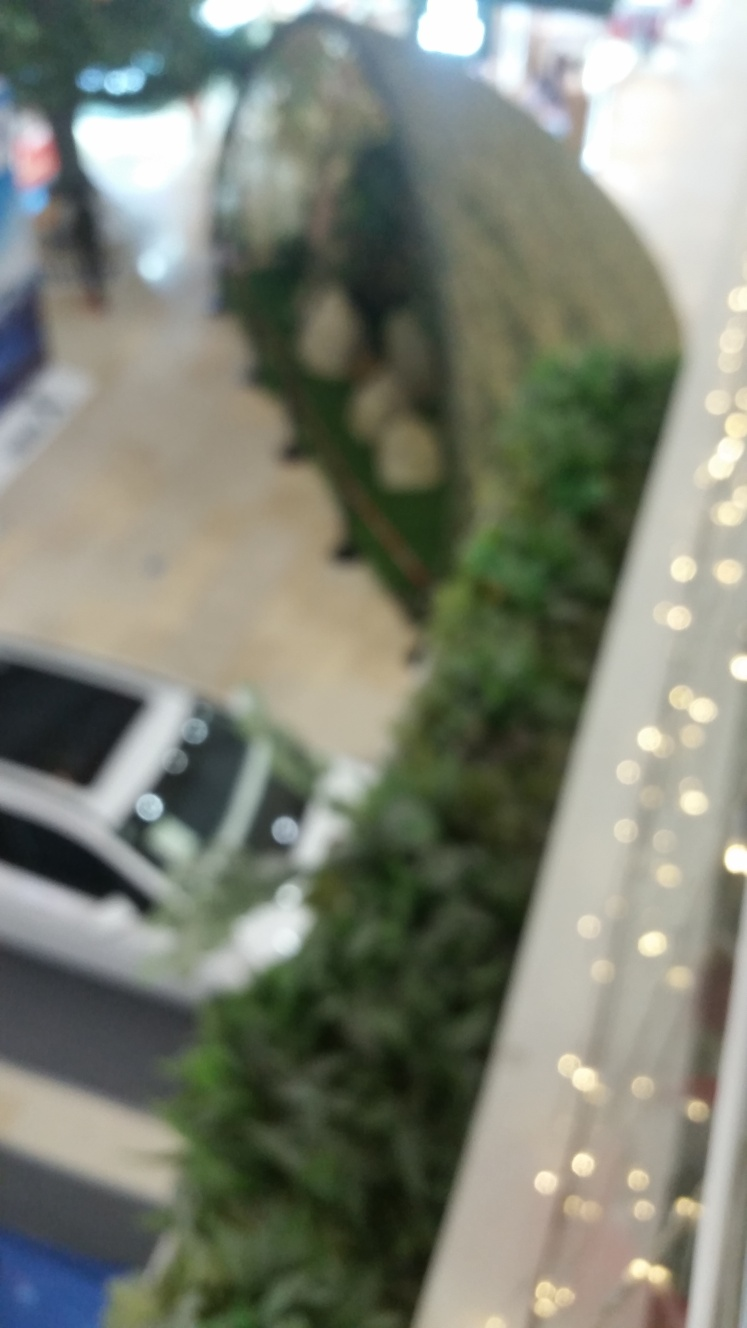What details can you describe about the architecture or design in this image? Despite the blur, it's discernible that the design includes multiple levels, indicating a multi-story structure. There are railings visible, suggesting balconies or walkways overlooking a central area. The use of indoor plants is also noticeable, contributing to an aesthetic aspect within the design. Could you guess at the purpose of the lower level in this image? It's difficult to pinpoint the exact purpose without clarity, but the lower level likely serves as a commercial or social gathering space. This could be inferred from the vague shapes that resemble cars, which, along with the presence of plants and railings, suggest a potential area for exhibits, displays, or a relaxation zone within a commercial setting. 